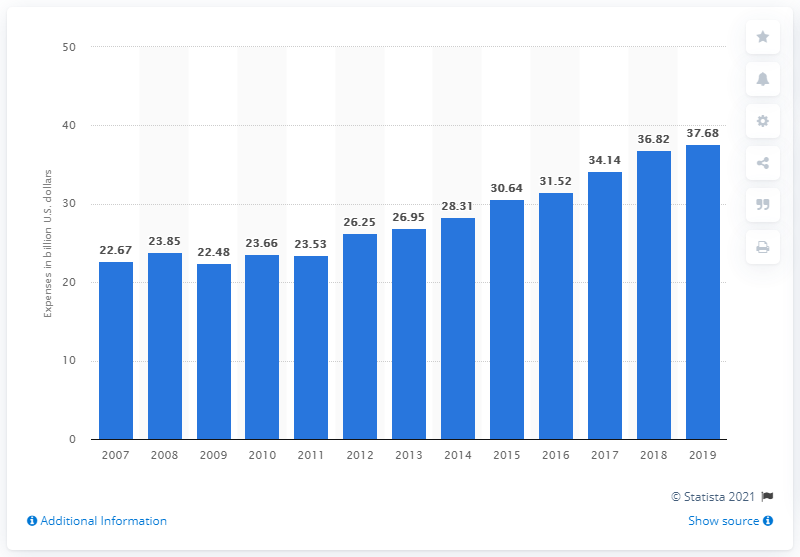Indicate a few pertinent items in this graphic. In the previous year, companies in the advertising industry collectively spent approximately 36.82... on their advertising efforts. The advertising agencies in the United States spent approximately 37.68 billion dollars in 2018. 